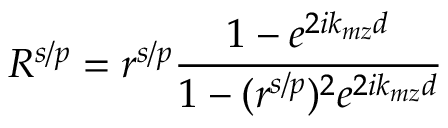<formula> <loc_0><loc_0><loc_500><loc_500>R ^ { s / p } = r ^ { s / p } \frac { 1 - e ^ { 2 i k _ { m z } d } } { 1 - ( r ^ { s / p } ) ^ { 2 } e ^ { 2 i k _ { m z } d } }</formula> 